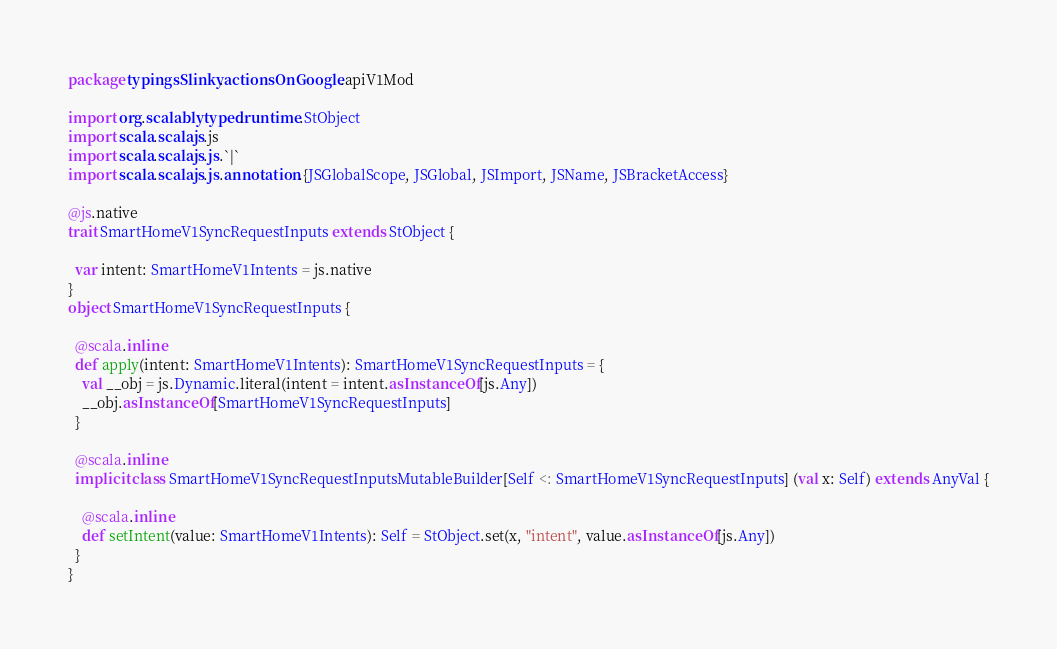Convert code to text. <code><loc_0><loc_0><loc_500><loc_500><_Scala_>package typingsSlinky.actionsOnGoogle.apiV1Mod

import org.scalablytyped.runtime.StObject
import scala.scalajs.js
import scala.scalajs.js.`|`
import scala.scalajs.js.annotation.{JSGlobalScope, JSGlobal, JSImport, JSName, JSBracketAccess}

@js.native
trait SmartHomeV1SyncRequestInputs extends StObject {
  
  var intent: SmartHomeV1Intents = js.native
}
object SmartHomeV1SyncRequestInputs {
  
  @scala.inline
  def apply(intent: SmartHomeV1Intents): SmartHomeV1SyncRequestInputs = {
    val __obj = js.Dynamic.literal(intent = intent.asInstanceOf[js.Any])
    __obj.asInstanceOf[SmartHomeV1SyncRequestInputs]
  }
  
  @scala.inline
  implicit class SmartHomeV1SyncRequestInputsMutableBuilder[Self <: SmartHomeV1SyncRequestInputs] (val x: Self) extends AnyVal {
    
    @scala.inline
    def setIntent(value: SmartHomeV1Intents): Self = StObject.set(x, "intent", value.asInstanceOf[js.Any])
  }
}
</code> 